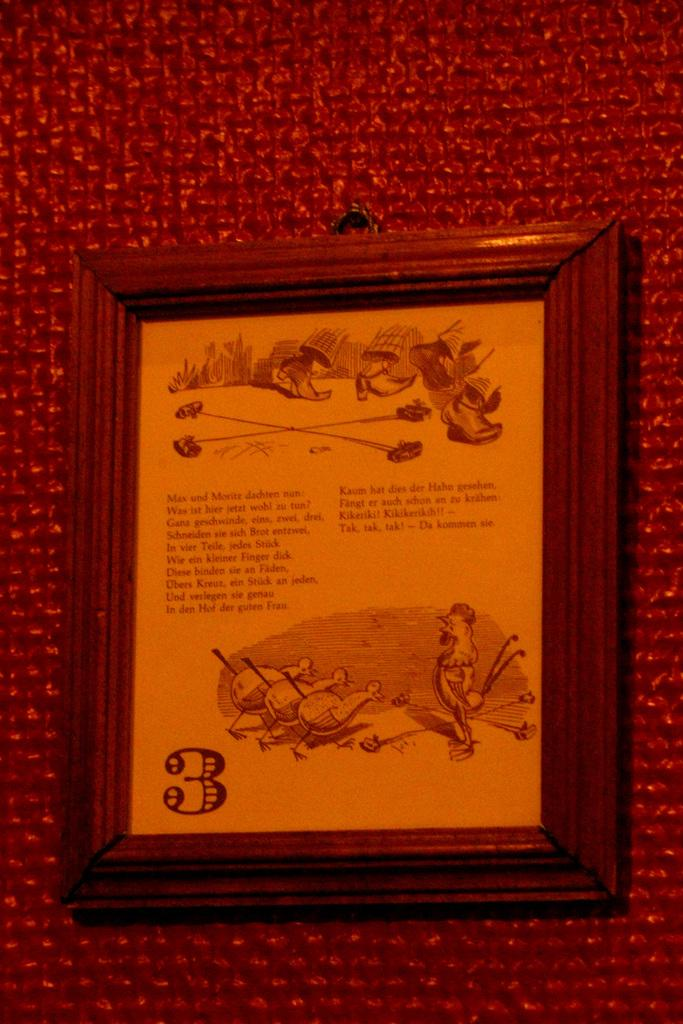What object is present in the image that typically holds a photograph or artwork? There is a photo frame in the image. What is inside the photo frame? The photo frame contains a paper with text and pictures. What color is the background of the paper inside the photo frame? The background of the paper inside the photo frame is red. How many brothers are depicted in the image? There are no brothers depicted in the image; it features a photo frame with a paper containing text and pictures. What color are the eyes of the person in the image? There is no person present in the image, only a photo frame with a paper containing text and pictures. 